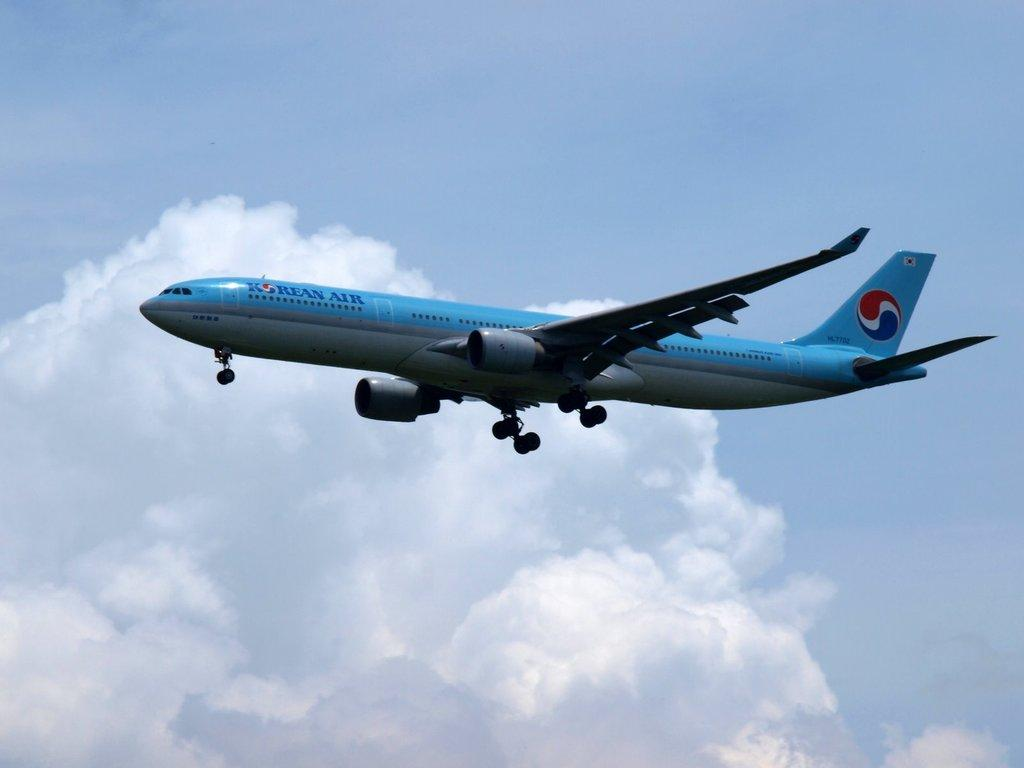<image>
Write a terse but informative summary of the picture. The brand name of this airplane is called "Korean Air." 